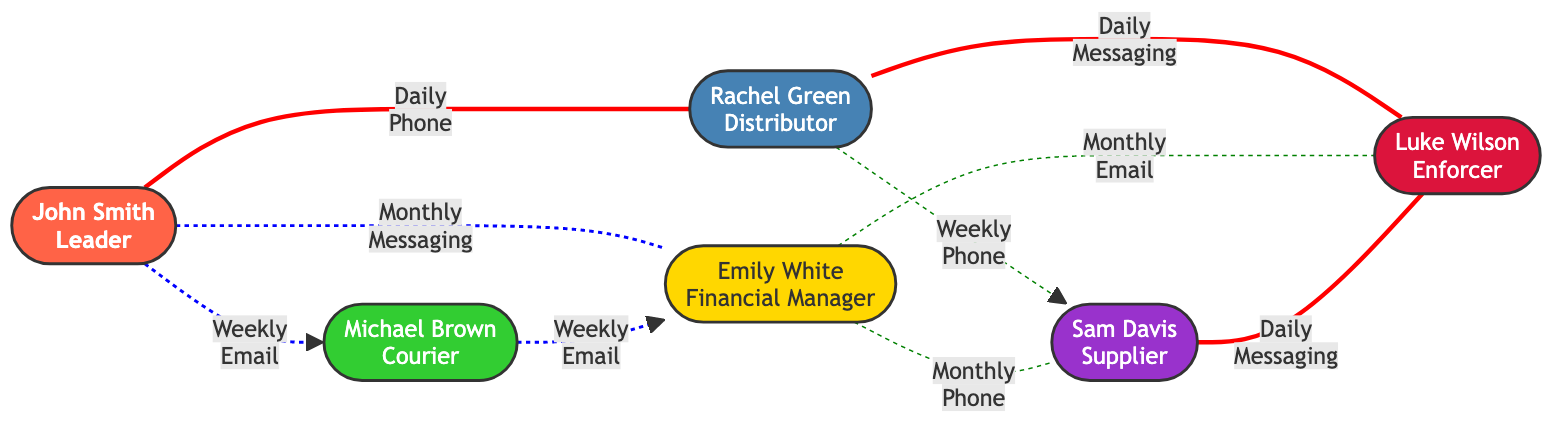What is the role of John Smith? The diagram specifies that John Smith is labeled as the "Leader," which is indicated directly in the node information for member1.
Answer: Leader How many total members are depicted in the diagram? By counting the nodes listed, there are six individual members represented in the diagram.
Answer: 6 Which member communicates daily with Rachel Green? From the edges, we can see that Luke Wilson communicates daily with Rachel Green, as indicated by the edge between member2 and member6 with the communication frequency labeled as "Daily."
Answer: Luke Wilson What is the communication channel used by John Smith to reach Emily White? The diagram shows that John Smith communicates with Emily White through a messaging app, as indicated by the edge labeled with "Monthly" and "Messaging."
Answer: Messaging app How often does Sam Davis communicate with Luke Wilson? Looking at the connections, we can see the edge between member5 and member6 indicates that Sam Davis communicates daily with Luke Wilson, as labeled in the diagram.
Answer: Daily How many distinct communication channels are used in the network? By examining the edges, the channels observed are phone, email, and messaging app, leading to a total of three distinct communication channels utilized.
Answer: 3 Which member has the most frequent communication with John Smith? Analyzing the edges, we find that Rachel Green has the most frequent communication with John Smith, occurring daily via phone as shown by the edge between member1 and member2.
Answer: Rachel Green What role does Emily White play within the drug ring? The diagram indicates that Emily White is identified as the "Financial Manager," which is a key role outlined among the six members.
Answer: Financial Manager Which two members communicate with each other through emails? The members who communicate via email are Michael Brown and Emily White, as seen from the edges demonstrating their weekly email communication.
Answer: Michael Brown and Emily White 